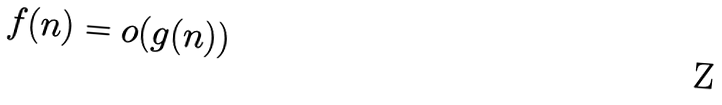<formula> <loc_0><loc_0><loc_500><loc_500>f ( n ) = o ( g ( n ) )</formula> 